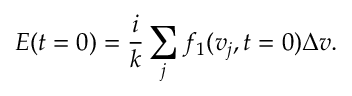<formula> <loc_0><loc_0><loc_500><loc_500>E ( t = 0 ) = \frac { i } { k } \sum _ { j } f _ { 1 } ( v _ { j } , t = 0 ) \Delta v .</formula> 